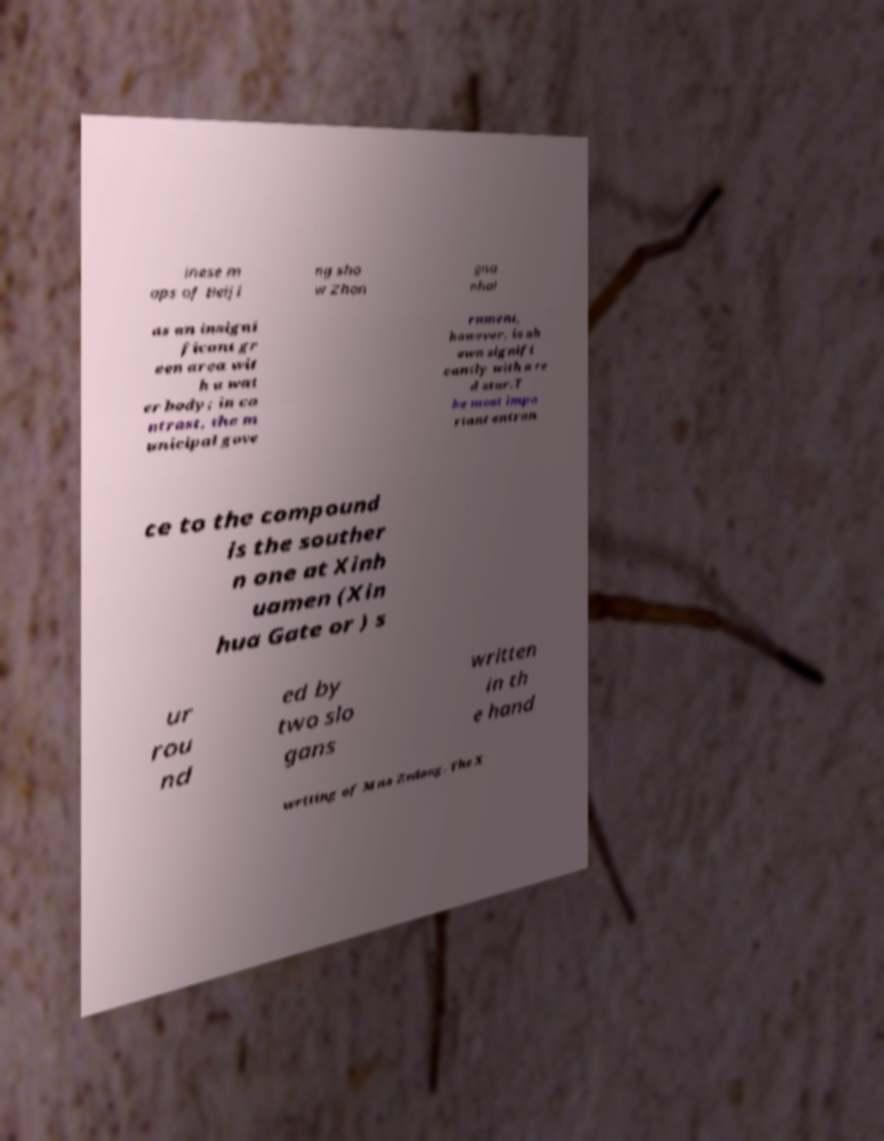Please read and relay the text visible in this image. What does it say? inese m aps of Beiji ng sho w Zhon gna nhai as an insigni ficant gr een area wit h a wat er body; in co ntrast, the m unicipal gove rnment, however, is sh own signifi cantly with a re d star.T he most impo rtant entran ce to the compound is the souther n one at Xinh uamen (Xin hua Gate or ) s ur rou nd ed by two slo gans written in th e hand writing of Mao Zedong. The X 